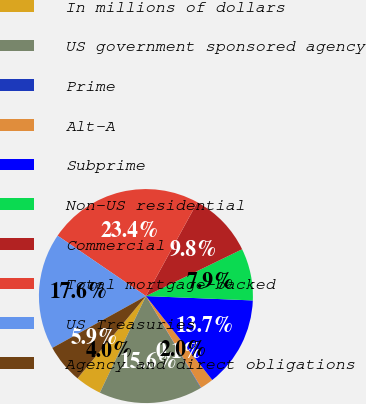Convert chart to OTSL. <chart><loc_0><loc_0><loc_500><loc_500><pie_chart><fcel>In millions of dollars<fcel>US government sponsored agency<fcel>Prime<fcel>Alt-A<fcel>Subprime<fcel>Non-US residential<fcel>Commercial<fcel>Total mortgage-backed<fcel>US Treasuries<fcel>Agency and direct obligations<nl><fcel>3.96%<fcel>15.65%<fcel>0.07%<fcel>2.01%<fcel>13.7%<fcel>7.86%<fcel>9.81%<fcel>23.44%<fcel>17.6%<fcel>5.91%<nl></chart> 